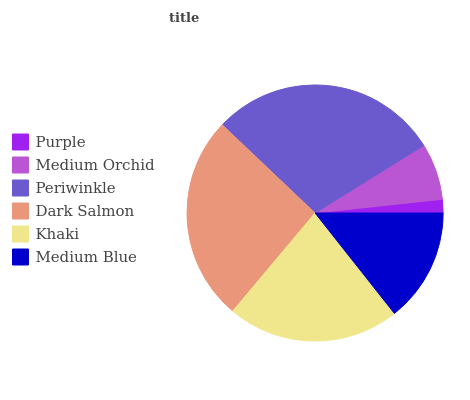Is Purple the minimum?
Answer yes or no. Yes. Is Periwinkle the maximum?
Answer yes or no. Yes. Is Medium Orchid the minimum?
Answer yes or no. No. Is Medium Orchid the maximum?
Answer yes or no. No. Is Medium Orchid greater than Purple?
Answer yes or no. Yes. Is Purple less than Medium Orchid?
Answer yes or no. Yes. Is Purple greater than Medium Orchid?
Answer yes or no. No. Is Medium Orchid less than Purple?
Answer yes or no. No. Is Khaki the high median?
Answer yes or no. Yes. Is Medium Blue the low median?
Answer yes or no. Yes. Is Medium Blue the high median?
Answer yes or no. No. Is Dark Salmon the low median?
Answer yes or no. No. 